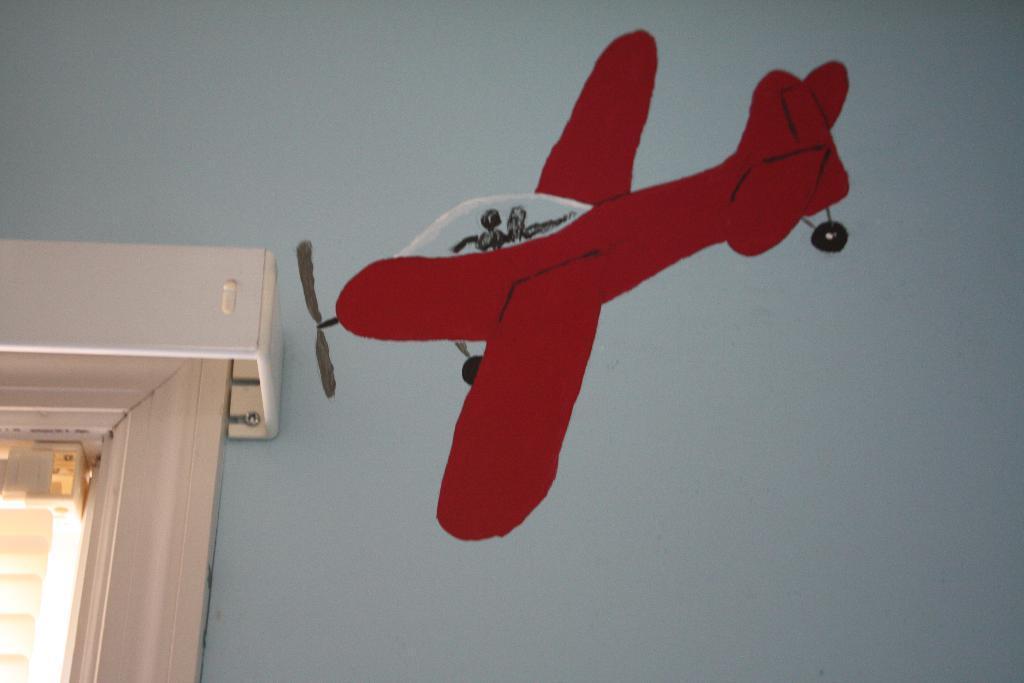Please provide a concise description of this image. In the image we can see the wall and on the wall there is painting of flying. Here we can see the window. 